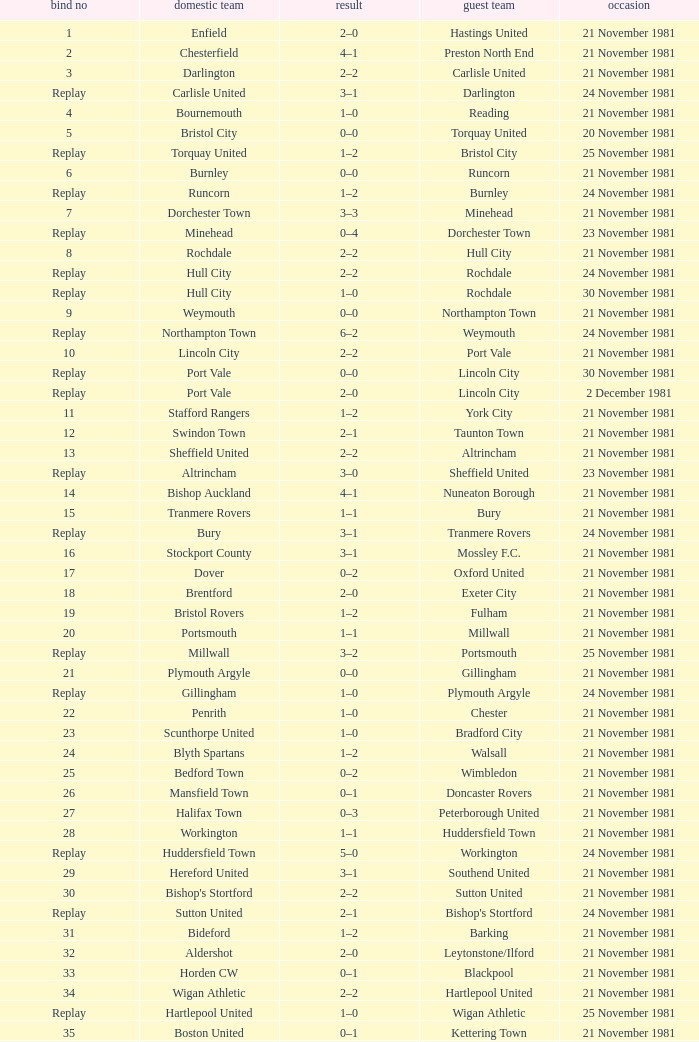Minehead has what tie number? Replay. 